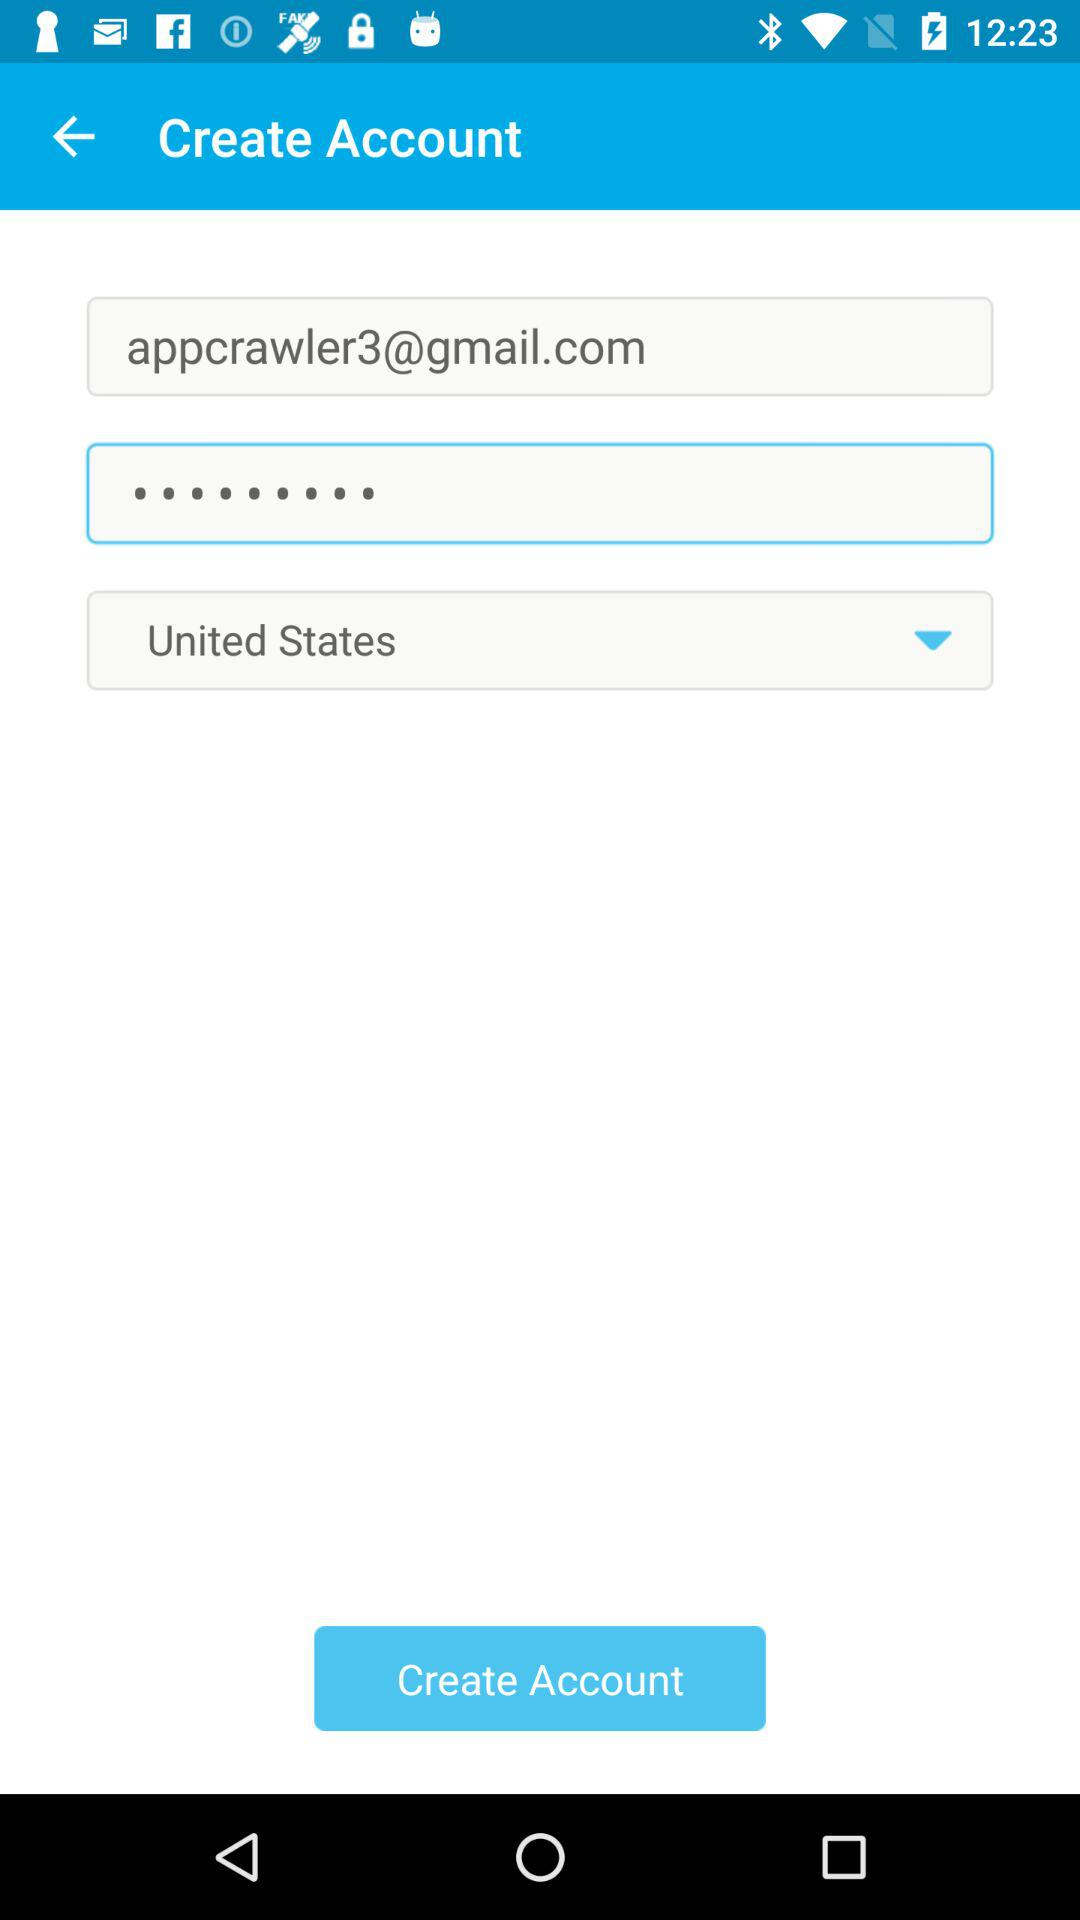What is the country name? The country name is the United States. 